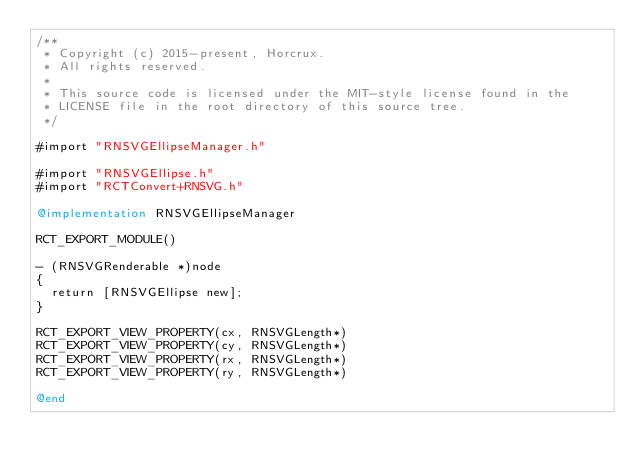<code> <loc_0><loc_0><loc_500><loc_500><_ObjectiveC_>/**
 * Copyright (c) 2015-present, Horcrux.
 * All rights reserved.
 *
 * This source code is licensed under the MIT-style license found in the
 * LICENSE file in the root directory of this source tree.
 */

#import "RNSVGEllipseManager.h"

#import "RNSVGEllipse.h"
#import "RCTConvert+RNSVG.h"

@implementation RNSVGEllipseManager

RCT_EXPORT_MODULE()

- (RNSVGRenderable *)node
{
  return [RNSVGEllipse new];
}

RCT_EXPORT_VIEW_PROPERTY(cx, RNSVGLength*)
RCT_EXPORT_VIEW_PROPERTY(cy, RNSVGLength*)
RCT_EXPORT_VIEW_PROPERTY(rx, RNSVGLength*)
RCT_EXPORT_VIEW_PROPERTY(ry, RNSVGLength*)

@end
</code> 